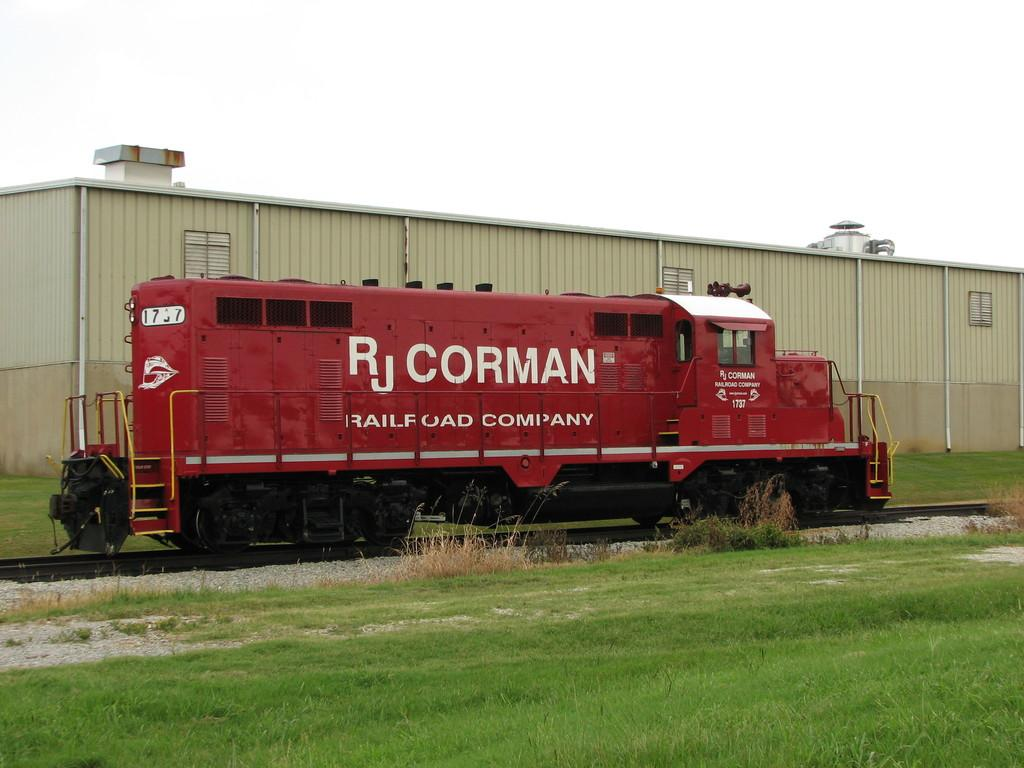Provide a one-sentence caption for the provided image. A red railway car that says RJ Corman on its side is parked. 